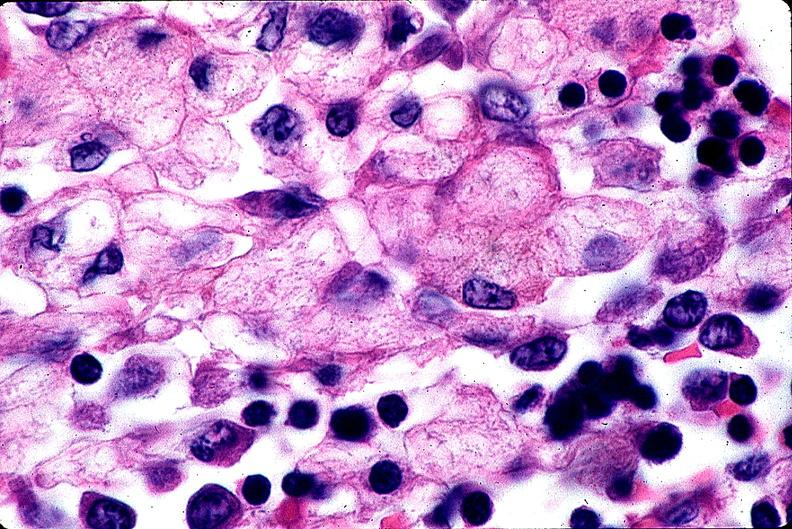s purulent sinusitis present?
Answer the question using a single word or phrase. No 